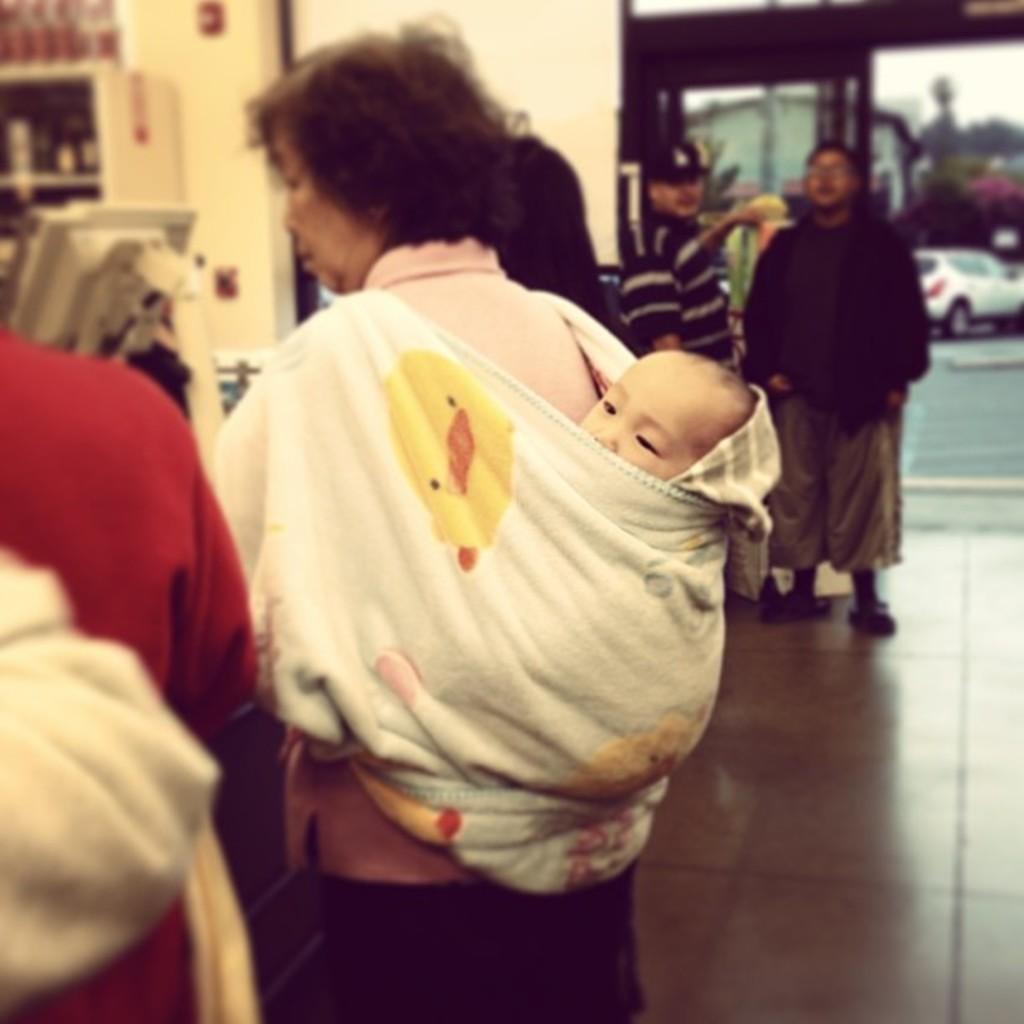Please provide a concise description of this image. In this picture I can see inner view of a building and few people are standing and I can see a woman carrying a baby on her back and I can see a monitor and few items on the shelves and I can see a car, trees and another building in the back. 